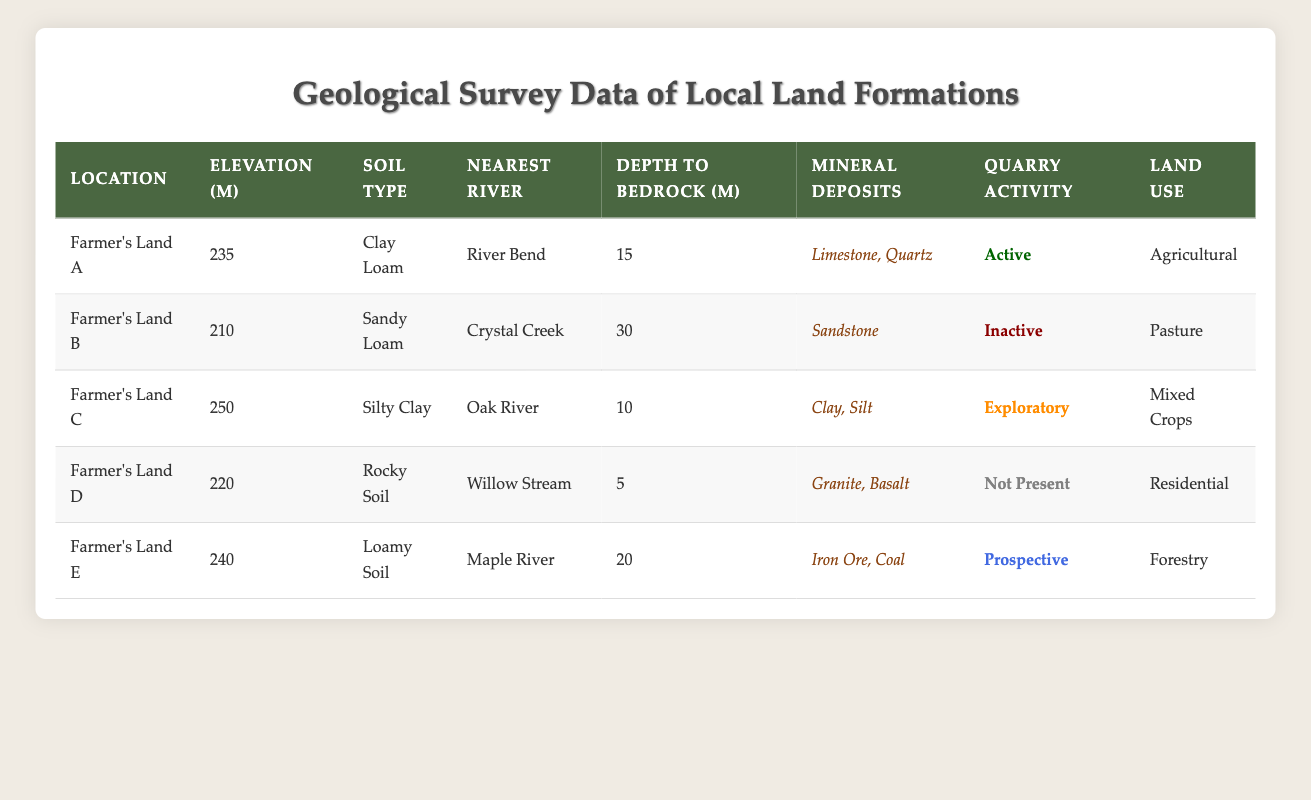What is the elevation of Farmer's Land C? The elevation for Farmer's Land C is listed directly in the table under the "Elevation (m)" column, which shows the value as 250 m.
Answer: 250 m Which location has the deepest depth to bedrock? To find the deepest depth to bedrock, look at the "Depth To Bedrock (m)" column and compare the values: 15, 30, 10, 5, and 20 for each location. Farmer's Land B has the highest value of 30 m.
Answer: Farmer's Land B Is the quarry activity on Farmer's Land D currently active? Checking the "Quarry Activity" column for Farmer's Land D shows the status as "Not Present," meaning there is no active quarry activity on that land.
Answer: No What mineral deposits are found on Farmer's Land E? The mineral deposits for Farmer's Land E are listed directly in the "Mineral Deposits" column, which shows that Iron Ore and Coal are present there.
Answer: Iron Ore, Coal How many locations have active quarry activity? From the "Quarry Activity" column, we can see that only Farmer's Land A has an "Active" designation. Counting this gives us a total of one active quarry.
Answer: 1 What is the elevation difference between Farmer's Land A and Farmer's Land D? The elevation for Farmer's Land A is 235 m and for Farmer's Land D is 220 m. The difference is calculated as 235 m - 220 m = 15 m.
Answer: 15 m Which soil type is the most common among the lands listed? Checking the "Soil Type" column reveals five different soil types: Clay Loam, Sandy Loam, Silty Clay, Rocky Soil, and Loamy Soil. Each type occurs only once, so there is no most common type.
Answer: None Are any of the lands used for residential purposes? Looking in the "Land Use" column, we see that only Farmer's Land D has the designation "Residential." This indicates that yes, there is a land used for residential purposes.
Answer: Yes Which location nearest to a river is classified as having "Exploratory" quarry activity? In the "Quarry Activity" column, Farmer's Land C is labeled "Exploratory." Checking the "Nearest River" column confirms it is nearest to Oak River.
Answer: Farmer's Land C 